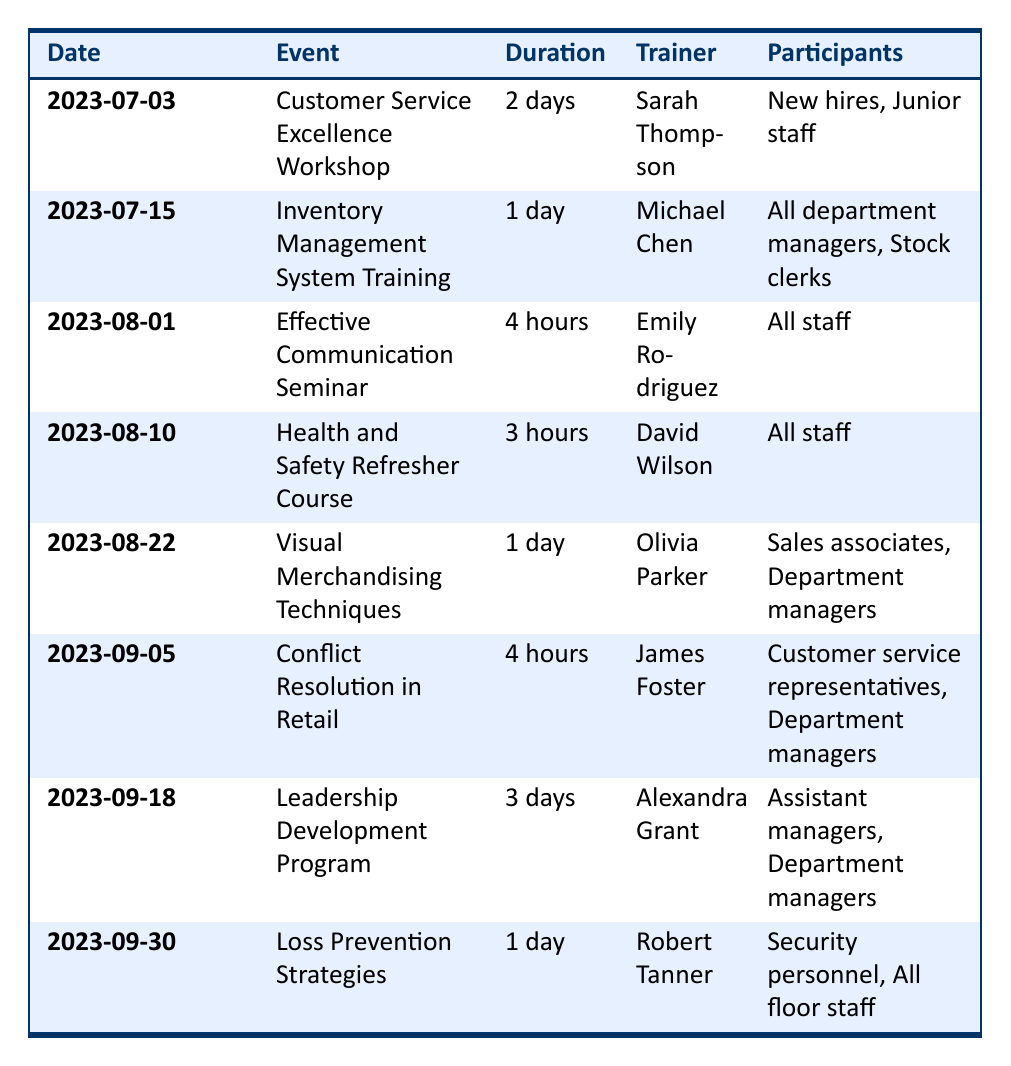What is the duration of the Customer Service Excellence Workshop? The duration for the Customer Service Excellence Workshop is listed in the table under the Duration column for the corresponding event date. It states "2 days."
Answer: 2 days Who is the trainer for the Health and Safety Refresher Course? By locating the Health and Safety Refresher Course in the table, I can find the trainer's name in the Trainer column for that specific event date, which is "David Wilson."
Answer: David Wilson How many days does the Leadership Development Program last? The table shows the duration for the Leadership Development Program under the Duration column for the event date provided, which is "3 days."
Answer: 3 days Are all staff required to attend the Effective Communication Seminar? Referring to the Participants column for the Effective Communication Seminar, it states "All staff," confirming that all team members are required to attend this training.
Answer: Yes Which event is scheduled for the latest date in the table? The latest date is found by comparing all event dates in the Date column. The most recent date listed is "2023-09-30," which corresponds to the Loss Prevention Strategies event.
Answer: Loss Prevention Strategies How many hours of training are scheduled in total for all events listed? I will add the durations of each event, converting all durations to hours: 2 days = 48 hours, 1 day = 8 hours, 4 hours, 3 hours, 1 day = 8 hours, 4 hours, 3 days = 72 hours, 1 day = 8 hours, resulting in the total: 48 + 8 + 4 + 3 + 8 + 4 + 72 + 8 = 155 hours.
Answer: 155 hours Is there any training specifically for stock clerks? Checking the Participants column, the Inventory Management System Training on "2023-07-15" lists "Stock clerks" among the participants, confirming there is training for them.
Answer: Yes What percentage of the events are led by Alexandra Grant? There is 1 event led by Alexandra Grant out of a total of 8 events. The percentage is calculated as (1/8) * 100 = 12.5%.
Answer: 12.5% 